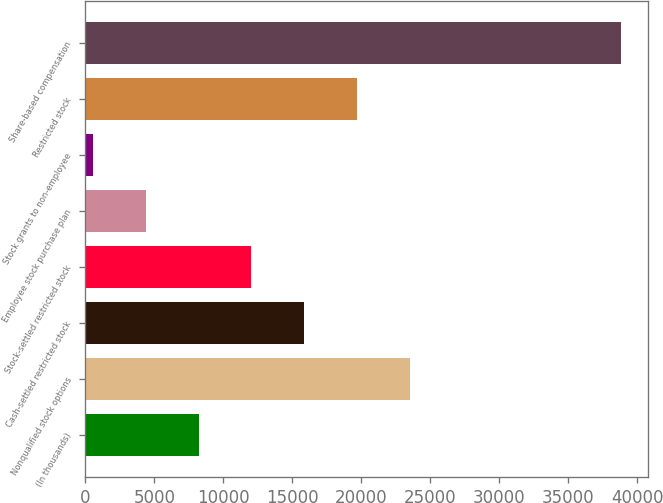Convert chart to OTSL. <chart><loc_0><loc_0><loc_500><loc_500><bar_chart><fcel>(In thousands)<fcel>Nonqualified stock options<fcel>Cash-settled restricted stock<fcel>Stock-settled restricted stock<fcel>Employee stock purchase plan<fcel>Stock grants to non-employee<fcel>Restricted stock<fcel>Share-based compensation<nl><fcel>8208.8<fcel>23526.4<fcel>15867.6<fcel>12038.2<fcel>4379.4<fcel>550<fcel>19697<fcel>38844<nl></chart> 